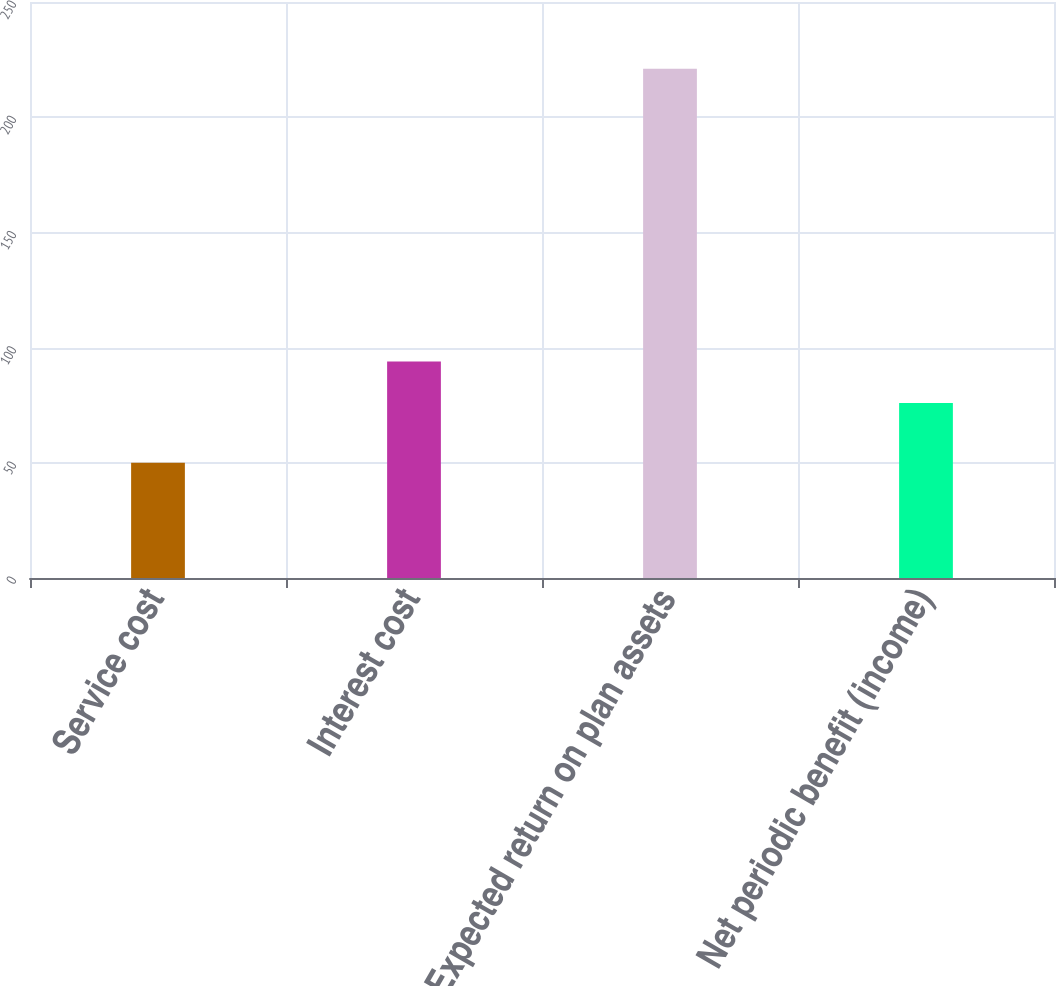<chart> <loc_0><loc_0><loc_500><loc_500><bar_chart><fcel>Service cost<fcel>Interest cost<fcel>Expected return on plan assets<fcel>Net periodic benefit (income)<nl><fcel>50<fcel>94<fcel>221<fcel>76<nl></chart> 